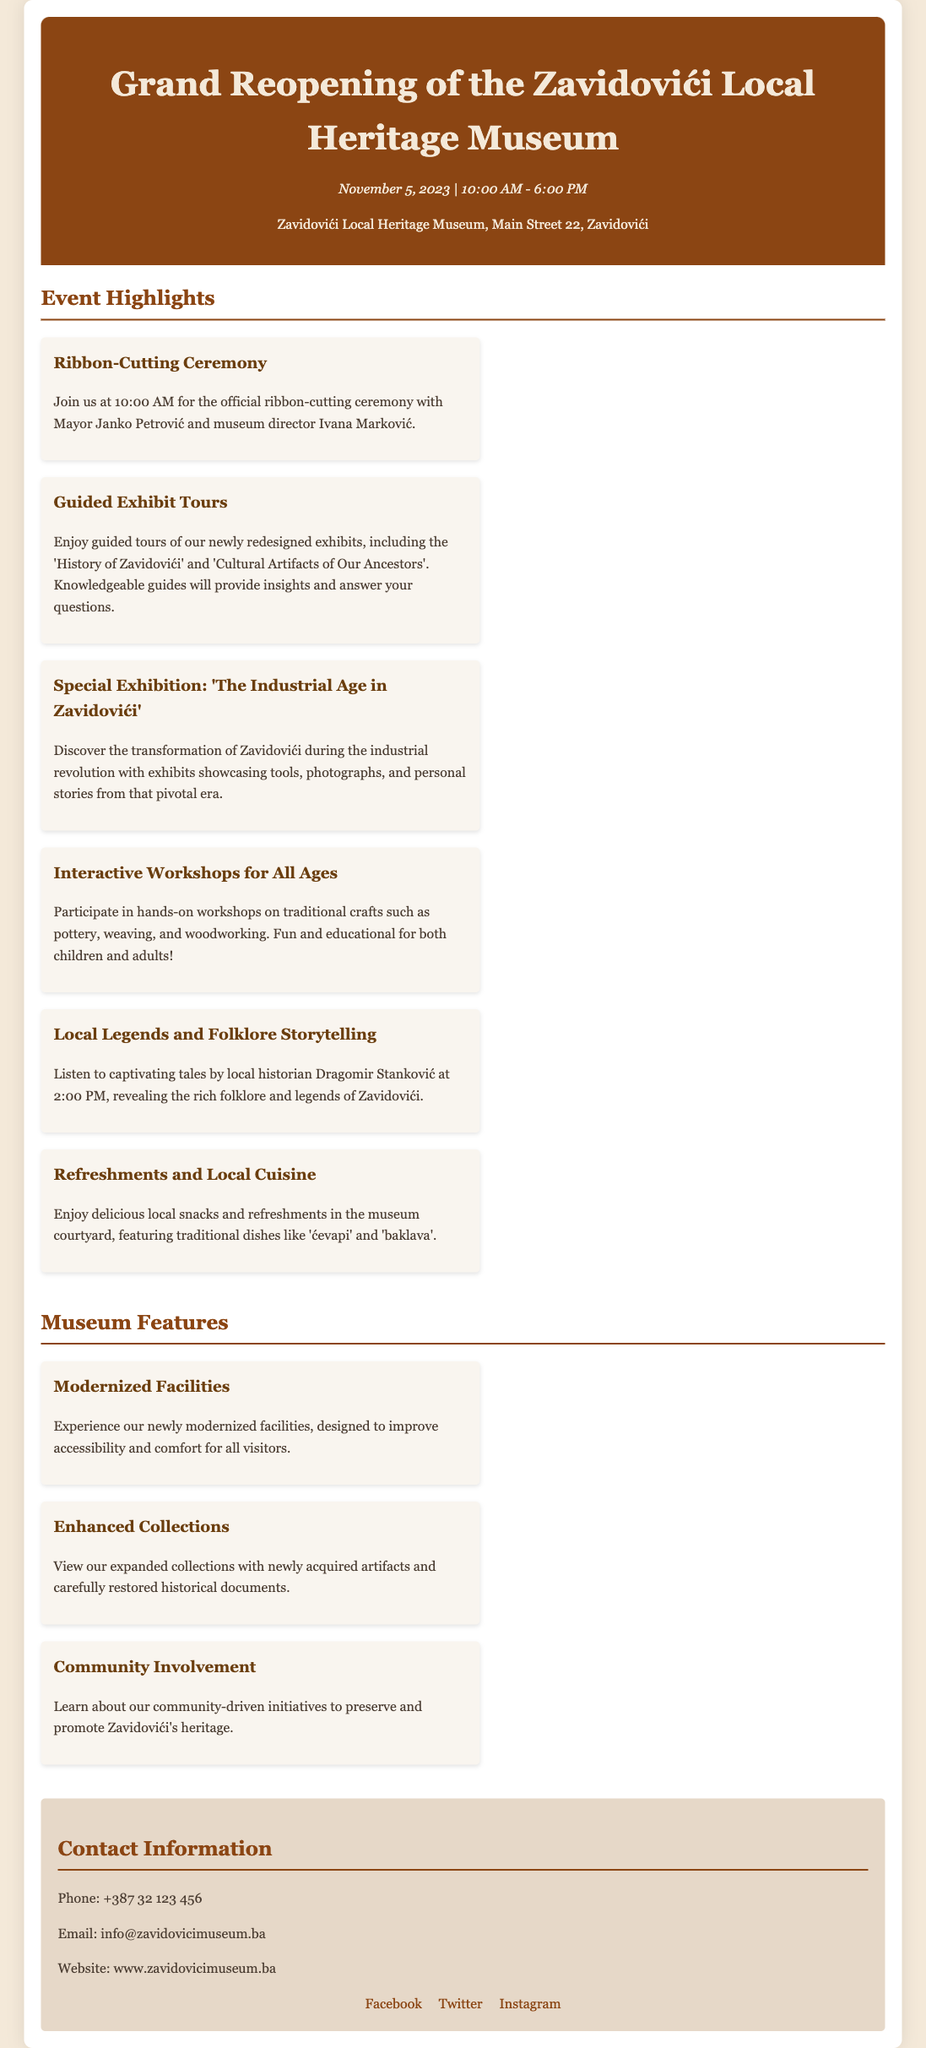What is the date of the reopening event? The date of the reopening event is specified in the document as November 5, 2023.
Answer: November 5, 2023 What time does the ribbon-cutting ceremony begin? The ribbon-cutting ceremony is mentioned to start at 10:00 AM in the document.
Answer: 10:00 AM Who will be attending the ribbon-cutting ceremony? The document states that Mayor Janko Petrović and museum director Ivana Marković will be present.
Answer: Mayor Janko Petrović and Ivana Marković What special exhibition will be featured? The document highlights a special exhibition titled 'The Industrial Age in Zavidovići'.
Answer: 'The Industrial Age in Zavidovići' What type of workshops will be offered? The document mentions interactive workshops on traditional crafts, indicating they are hands-on activities.
Answer: Traditional crafts Who will tell local legends and folklore stories? The document states that local historian Dragomir Stanković will be sharing stories during the event.
Answer: Dragomir Stanković What refreshments will be available at the museum? The document lists local snacks and traditional dishes like 'ćevapi' and 'baklava' as refreshments.
Answer: 'ćevapi' and 'baklava' What is the phone number for contacting the museum? The document provides the phone number as +387 32 123 456 for inquiries.
Answer: +387 32 123 456 